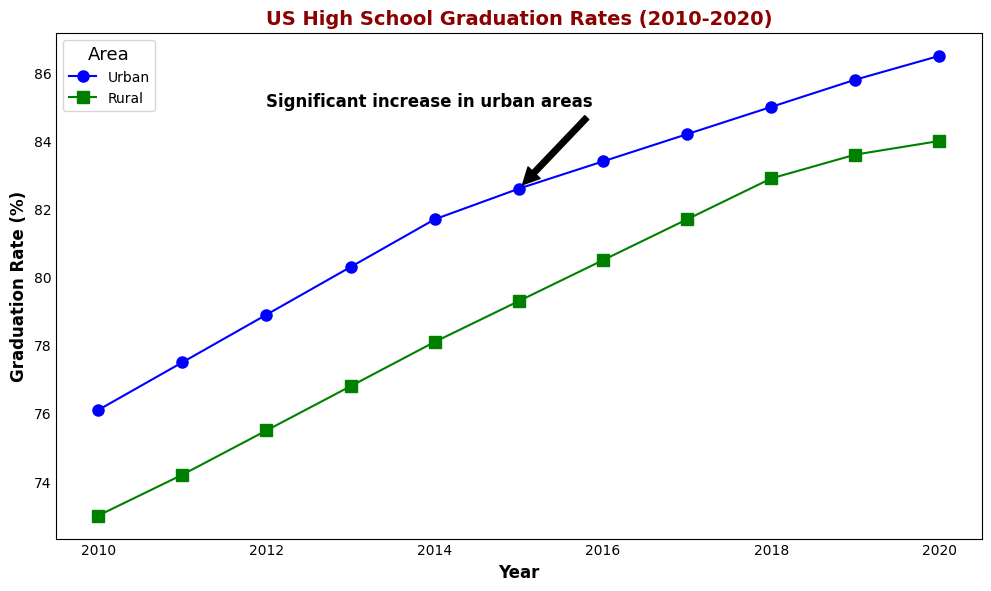What's the urban graduation rate in 2013? The urban graduation rate in 2013 can be directly found by looking at the data point on the urban line for the year 2013.
Answer: 80.3% Which area had a higher graduation rate in 2016, urban or rural? By comparing the two lines for the year 2016, the urban graduation rate is at 83.4% whereas the rural graduation rate is at 80.5%, so the urban area had a higher rate.
Answer: Urban What is the average graduation rate for rural areas between 2015 and 2017? The rates for rural areas in 2015, 2016, and 2017 are 79.3%, 80.5%, and 81.7% respectively. (79.3 + 80.5 + 81.7)/3 = 80.5
Answer: 80.5% When is the significant increase in urban graduation rates annotated? The annotation text points to the year 2015 and mentions a significant increase in urban areas.
Answer: 2015 What's the difference in graduation rates between urban and rural areas in 2010? The urban graduation rate in 2010 is 76.1% and the rural graduation rate is 73.0%. The difference is 76.1 - 73.0 = 3.1
Answer: 3.1 Did both urban and rural graduation rates increase from 2010 to 2020? From the lines on the plot, both urban and rural graduation rates show an increasing trend from 2010 (76.1% for urban and 73.0% for rural) to 2020 (86.5% for urban and 84.0% for rural).
Answer: Yes What's the trend of the urban graduation rate over the years? By observing the urban graduation rate line, it shows a consistent increase from 2010 to 2020.
Answer: Increasing In which year did the rural graduation rate first surpass 80%? By following the rural line, it is in 2016 when the rural graduation rate surpassed 80% for the first time, reaching 80.5%.
Answer: 2016 How much did the urban graduation rate increase from 2011 to 2014? The urban graduation rate in 2011 is 77.5% and in 2014 it is 81.7%. The increase is 81.7 - 77.5 = 4.2
Answer: 4.2 